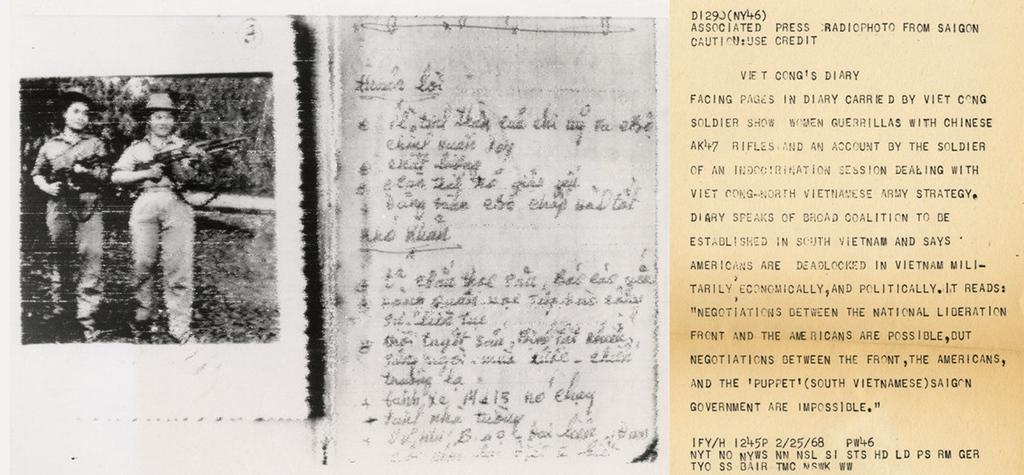What is the main subject of the image? The main subject of the image is a collage of photos. Can you describe the scene on the left side of the collage? There are two persons standing and holding guns on the left side of the collage. What is present on the right side of the collage? There is text written on the right side of the collage. What type of blade is being used by the persons in the image? There is no blade present in the image; the persons are holding guns. 